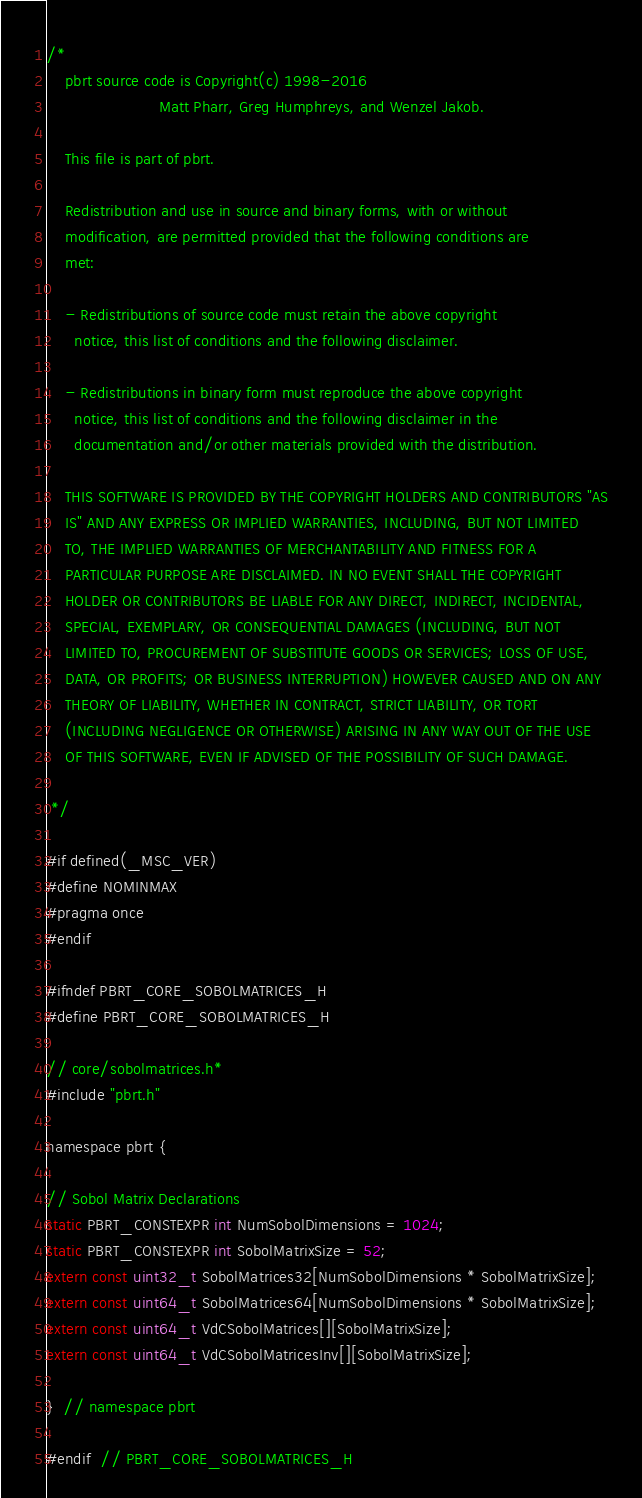<code> <loc_0><loc_0><loc_500><loc_500><_C_>
/*
    pbrt source code is Copyright(c) 1998-2016
                        Matt Pharr, Greg Humphreys, and Wenzel Jakob.

    This file is part of pbrt.

    Redistribution and use in source and binary forms, with or without
    modification, are permitted provided that the following conditions are
    met:

    - Redistributions of source code must retain the above copyright
      notice, this list of conditions and the following disclaimer.

    - Redistributions in binary form must reproduce the above copyright
      notice, this list of conditions and the following disclaimer in the
      documentation and/or other materials provided with the distribution.

    THIS SOFTWARE IS PROVIDED BY THE COPYRIGHT HOLDERS AND CONTRIBUTORS "AS
    IS" AND ANY EXPRESS OR IMPLIED WARRANTIES, INCLUDING, BUT NOT LIMITED
    TO, THE IMPLIED WARRANTIES OF MERCHANTABILITY AND FITNESS FOR A
    PARTICULAR PURPOSE ARE DISCLAIMED. IN NO EVENT SHALL THE COPYRIGHT
    HOLDER OR CONTRIBUTORS BE LIABLE FOR ANY DIRECT, INDIRECT, INCIDENTAL,
    SPECIAL, EXEMPLARY, OR CONSEQUENTIAL DAMAGES (INCLUDING, BUT NOT
    LIMITED TO, PROCUREMENT OF SUBSTITUTE GOODS OR SERVICES; LOSS OF USE,
    DATA, OR PROFITS; OR BUSINESS INTERRUPTION) HOWEVER CAUSED AND ON ANY
    THEORY OF LIABILITY, WHETHER IN CONTRACT, STRICT LIABILITY, OR TORT
    (INCLUDING NEGLIGENCE OR OTHERWISE) ARISING IN ANY WAY OUT OF THE USE
    OF THIS SOFTWARE, EVEN IF ADVISED OF THE POSSIBILITY OF SUCH DAMAGE.

 */

#if defined(_MSC_VER)
#define NOMINMAX
#pragma once
#endif

#ifndef PBRT_CORE_SOBOLMATRICES_H
#define PBRT_CORE_SOBOLMATRICES_H

// core/sobolmatrices.h*
#include "pbrt.h"

namespace pbrt {

// Sobol Matrix Declarations
static PBRT_CONSTEXPR int NumSobolDimensions = 1024;
static PBRT_CONSTEXPR int SobolMatrixSize = 52;
extern const uint32_t SobolMatrices32[NumSobolDimensions * SobolMatrixSize];
extern const uint64_t SobolMatrices64[NumSobolDimensions * SobolMatrixSize];
extern const uint64_t VdCSobolMatrices[][SobolMatrixSize];
extern const uint64_t VdCSobolMatricesInv[][SobolMatrixSize];

}  // namespace pbrt

#endif  // PBRT_CORE_SOBOLMATRICES_H
</code> 